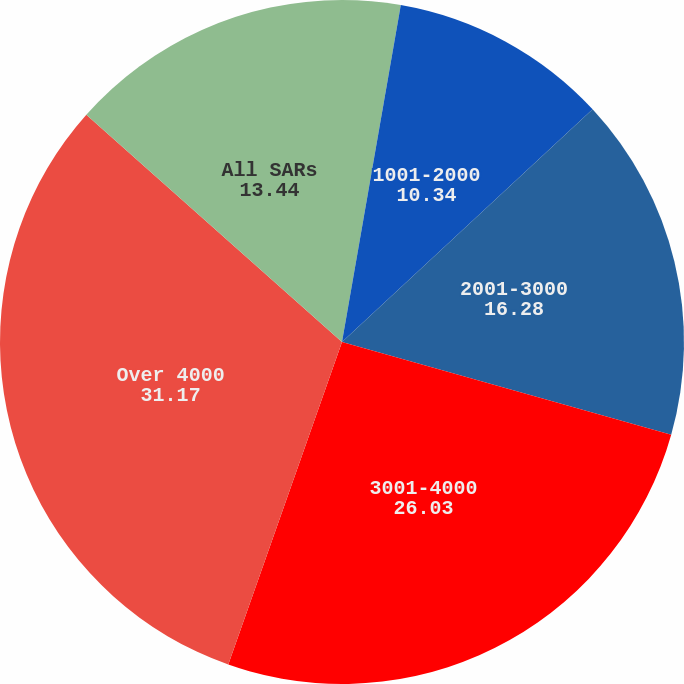<chart> <loc_0><loc_0><loc_500><loc_500><pie_chart><fcel>Under 1000<fcel>1001-2000<fcel>2001-3000<fcel>3001-4000<fcel>Over 4000<fcel>All SARs<nl><fcel>2.75%<fcel>10.34%<fcel>16.28%<fcel>26.03%<fcel>31.17%<fcel>13.44%<nl></chart> 